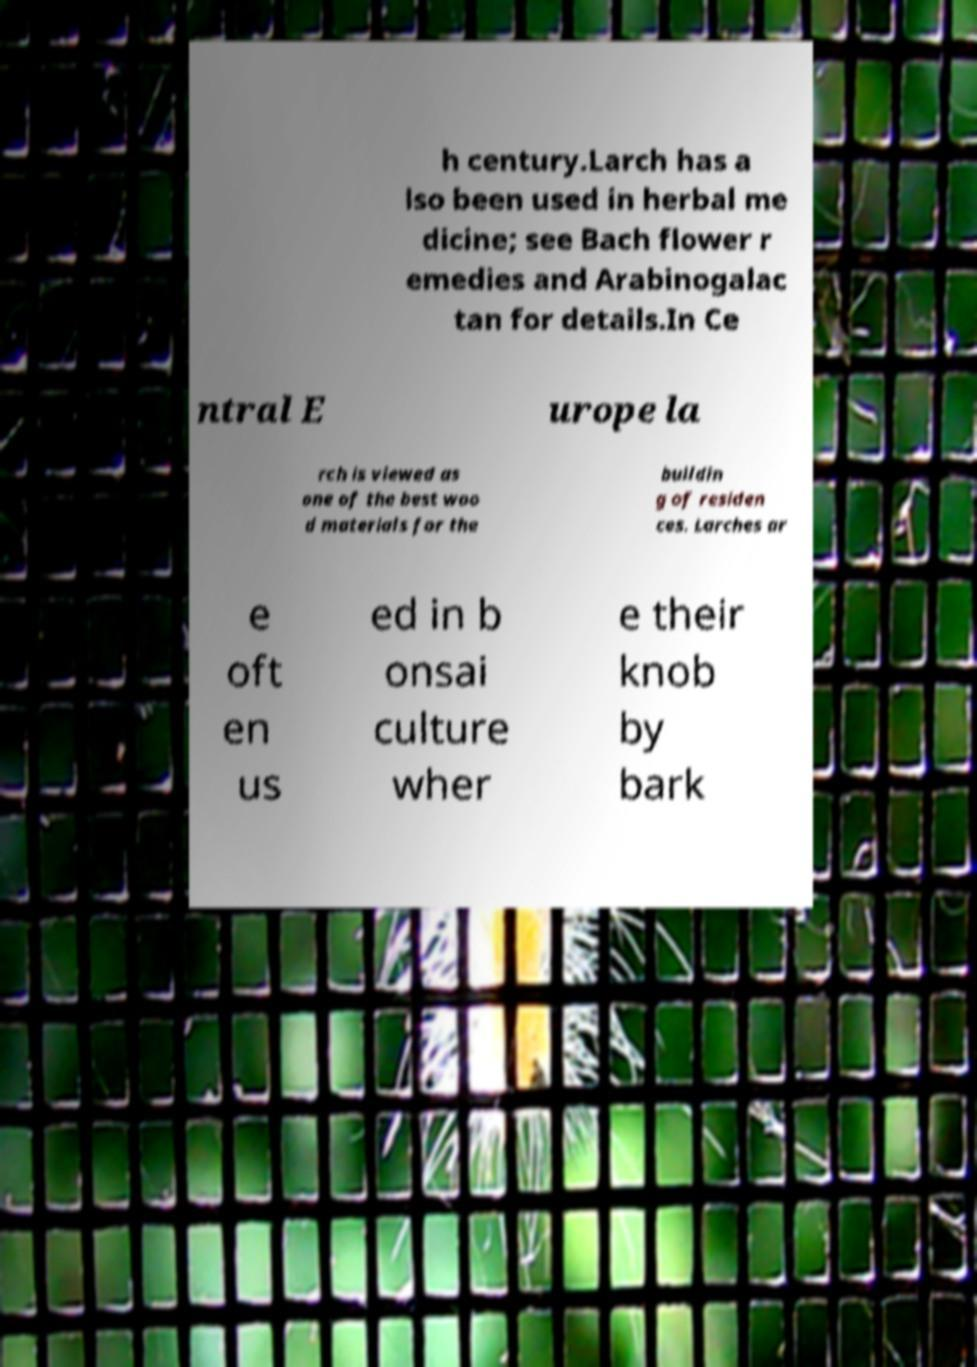Can you read and provide the text displayed in the image?This photo seems to have some interesting text. Can you extract and type it out for me? h century.Larch has a lso been used in herbal me dicine; see Bach flower r emedies and Arabinogalac tan for details.In Ce ntral E urope la rch is viewed as one of the best woo d materials for the buildin g of residen ces. Larches ar e oft en us ed in b onsai culture wher e their knob by bark 